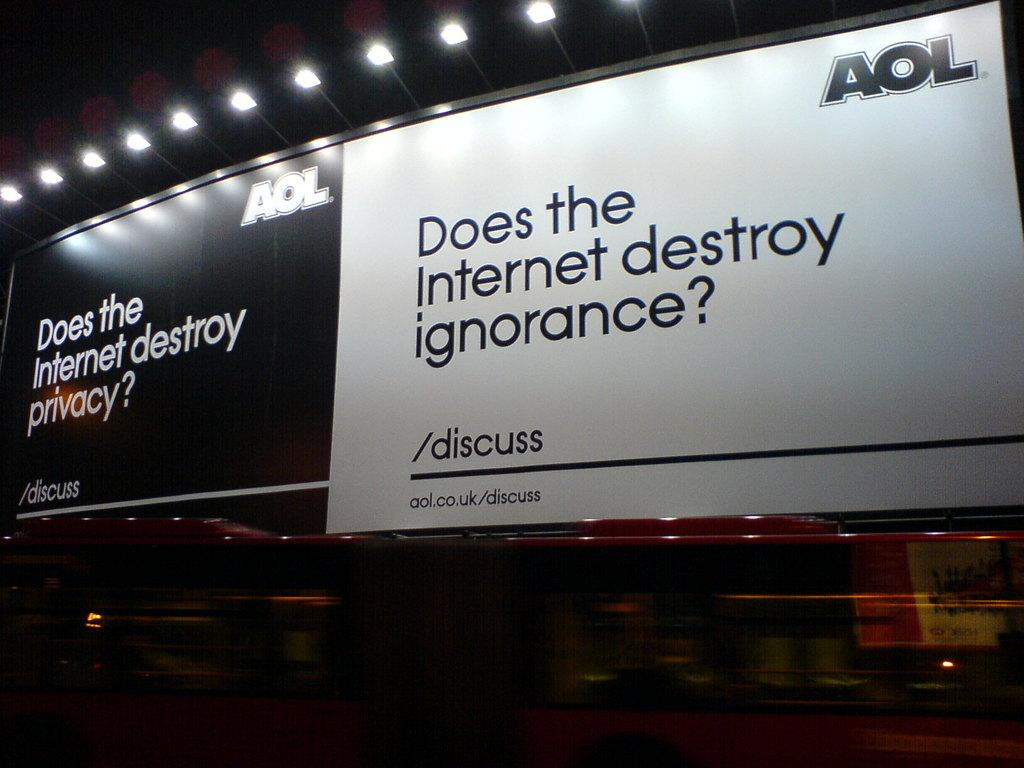<image>
Offer a succinct explanation of the picture presented. A pair of AOL billboards pose provocative questions. 